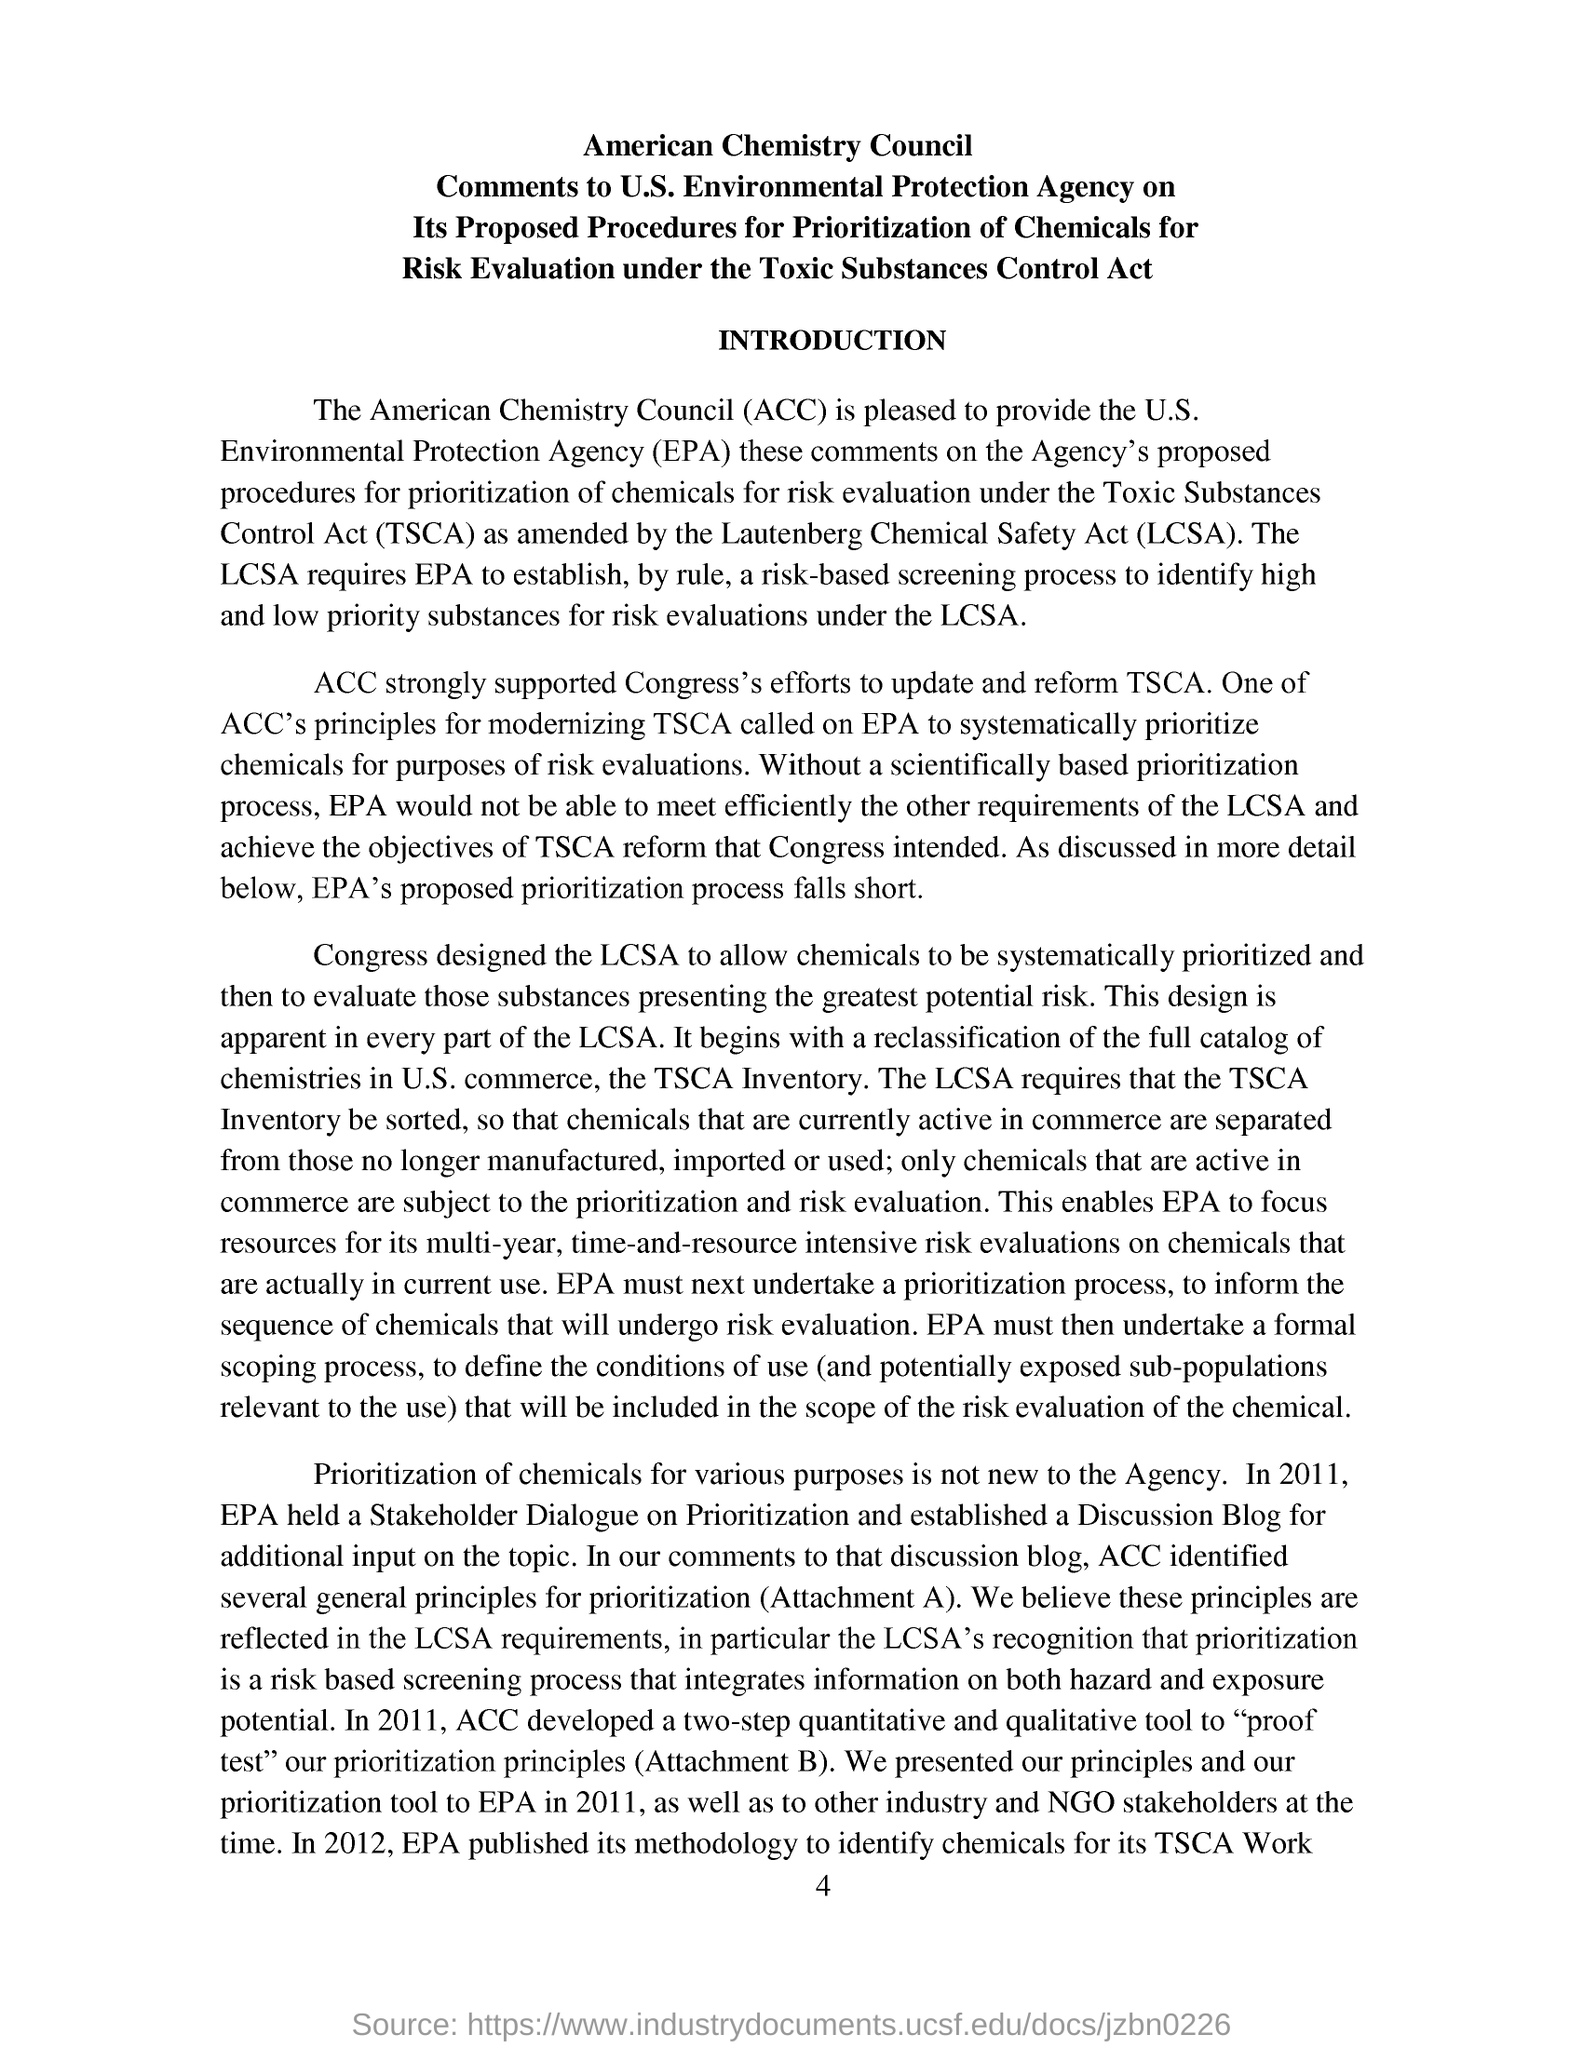What does the document suggest about the proposed prioritization process for chemicals? The document suggests that the American Chemistry Council (ACC) finds the proposed prioritization process by the Environmental Protection Agency (EPA) inadequate. The ACC's view is that the EPA's process potentially falls short in efficiently identifying high and low priority substances for risk evaluations under the TSCA. How does the ACC believe the prioritization process should be managed? The ACC believes the EPA should adopt a more scientifically based prioritization process. This would involve integrating information on both the hazards and exposure potential of a chemical, using quantitative tools to assess chemicals systematically. The aim is to ensure that the prioritization not only complies with the TSCA requirements but also truly reflects the relative risk that chemicals might pose to health and the environment. 